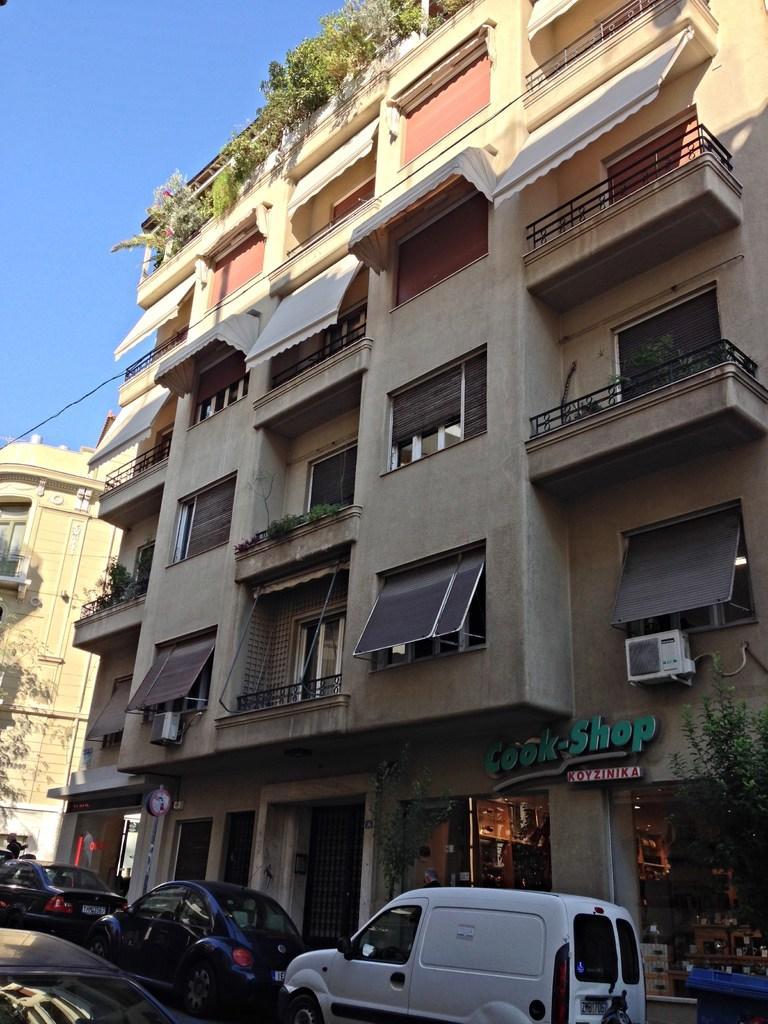Describe this image in one or two sentences. In the foreground of this image, at the bottom there are few vehicles. Behind it, there are buildings and plants. At the top, there is the sky. 